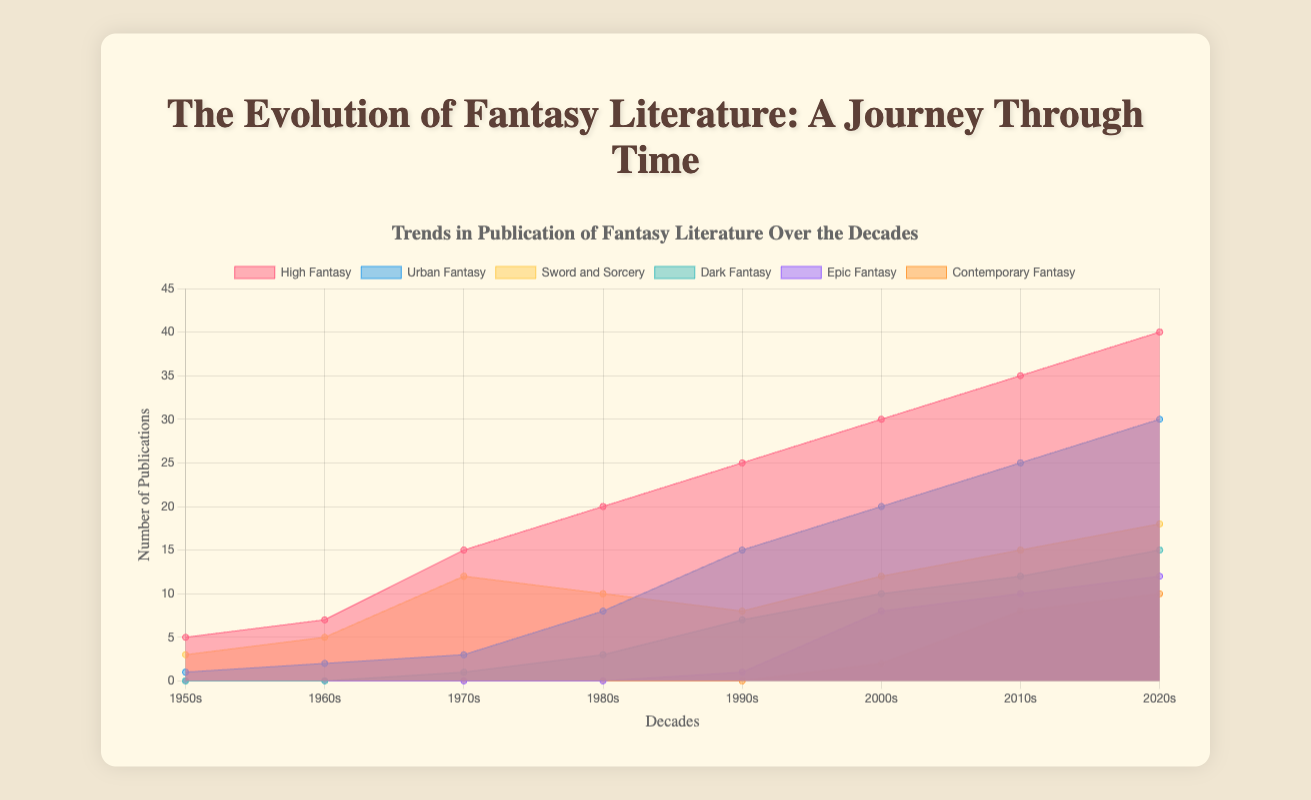What's the title of the chart? The title can be found at the top of the chart, which provides a description of the data visualized. It states the main subject of the figure.
Answer: Trends in Publication of Fantasy Literature Over the Decades How many decades are represented in the chart? The x-axis of the chart lists each decade that is being represented. Count the labels from 1950s to 2020s.
Answer: 8 Which fantasy subgenre had the highest number of publications in the 1990s? Look at the data points for each subgenre in the decade labeled "1990s" on the x-axis. Identify the subgenre with the highest value.
Answer: High Fantasy What is the trend for Urban Fantasy publications from 1950s to 2020s? Track the data points for Urban Fantasy across each decade from the 1950s to the 2020s. Note if the number of publications is increasing, decreasing, or stable.
Answer: Increasing Which subgenre had the most significant growth between the 1980s and 2020s? Compare the difference in the number of publications for each subgenre between the 1980s and 2020s. Identify which subgenre shows the greatest increase.
Answer: Urban Fantasy What was the total number of High Fantasy and Sword and Sorcery publications in the 2000s? Add the number of publications for High Fantasy and Sword and Sorcery in the 2000s. Sum these two values to find the total.
Answer: 42 How does the number of Epic Fantasy publications in the 2010s compare to those in the 2000s? Look at the number of Epic Fantasy publications in the 2000s and the 2010s. Determine if the number increased, decreased, or stayed the same.
Answer: Increased Identify the first decade Dark Fantasy appears in the chart? Examine each decade for the presence of Dark Fantasy data points. Identify the first decade where a non-zero value is present.
Answer: 1970s How does the publication trend of Sword and Sorcery compare to that of Contemporary Fantasy from the 2000s to the 2020s? Look at the data points for Sword and Sorcery and Contemporary Fantasy in the 2000s, 2010s, and 2020s. Compare the trends by noting any increases or decreases.
Answer: Both increased What was the average number of publications for Contemporary Fantasy in the 2010s and 2020s? Add the number of Contemporary Fantasy publications in the 2010s and 2020s. Divide the sum by 2 to get the average.
Answer: 9 